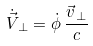<formula> <loc_0><loc_0><loc_500><loc_500>\dot { \vec { V } } _ { \, \perp } = \dot { \phi } \, \frac { \vec { v } _ { \, \perp } } { c }</formula> 